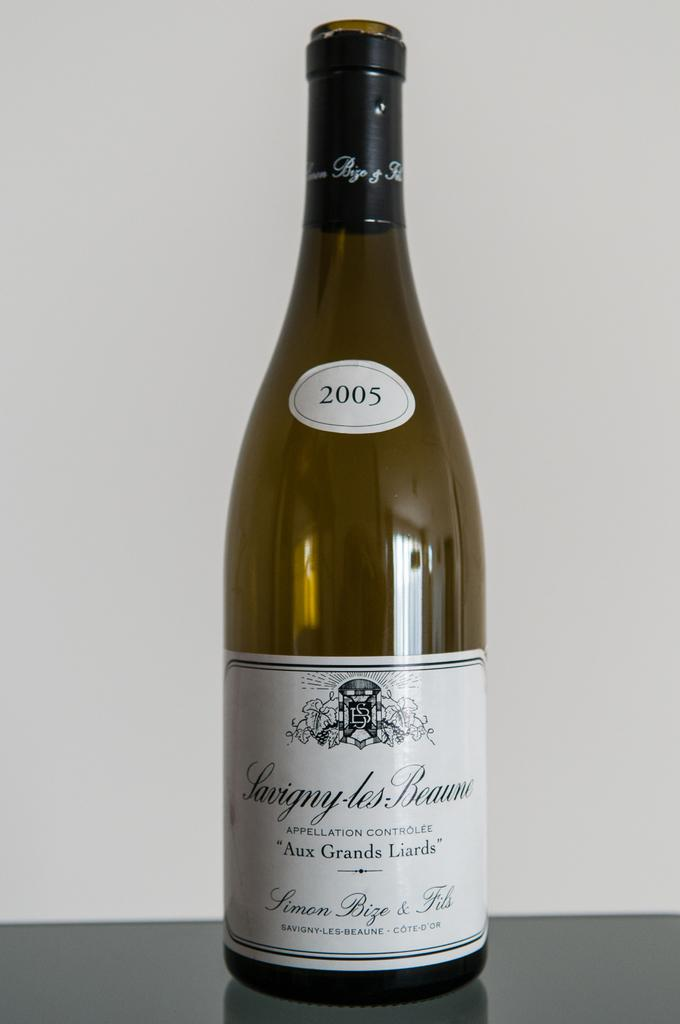What is the main object in the image? There is a wine bottle in the image. Are there any additional details on the wine bottle? Yes, the wine bottle has two stickers on it. What information can be found on the top sticker? The top sticker has the number 2005. Where is the office located in the image? There is no office present in the image; it only features a wine bottle with stickers. Can you point out the map on the wine bottle? There is no map present on the wine bottle; it only has two stickers with a number on one of them. 